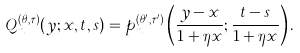<formula> <loc_0><loc_0><loc_500><loc_500>Q _ { n } ^ { ( \theta , \tau ) } ( y ; x , t , s ) = p _ { n } ^ { ( \theta ^ { \prime } , \tau ^ { \prime } ) } \left ( \frac { y - x } { 1 + \eta x } ; \frac { t - s } { 1 + \eta x } \right ) .</formula> 